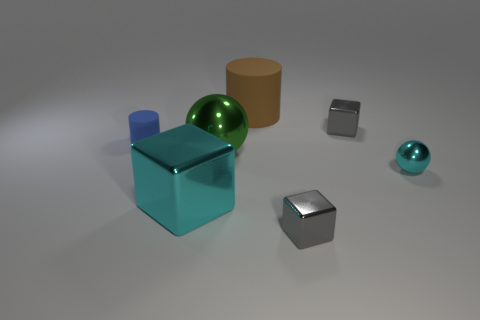Subtract all large cubes. How many cubes are left? 2 Add 1 gray cubes. How many objects exist? 8 Subtract all cyan blocks. How many blocks are left? 2 Subtract 2 cylinders. How many cylinders are left? 0 Subtract all cylinders. How many objects are left? 5 Subtract all large yellow metallic cylinders. Subtract all blue objects. How many objects are left? 6 Add 1 tiny blue rubber objects. How many tiny blue rubber objects are left? 2 Add 7 green spheres. How many green spheres exist? 8 Subtract 0 cyan cylinders. How many objects are left? 7 Subtract all gray cubes. Subtract all brown cylinders. How many cubes are left? 1 